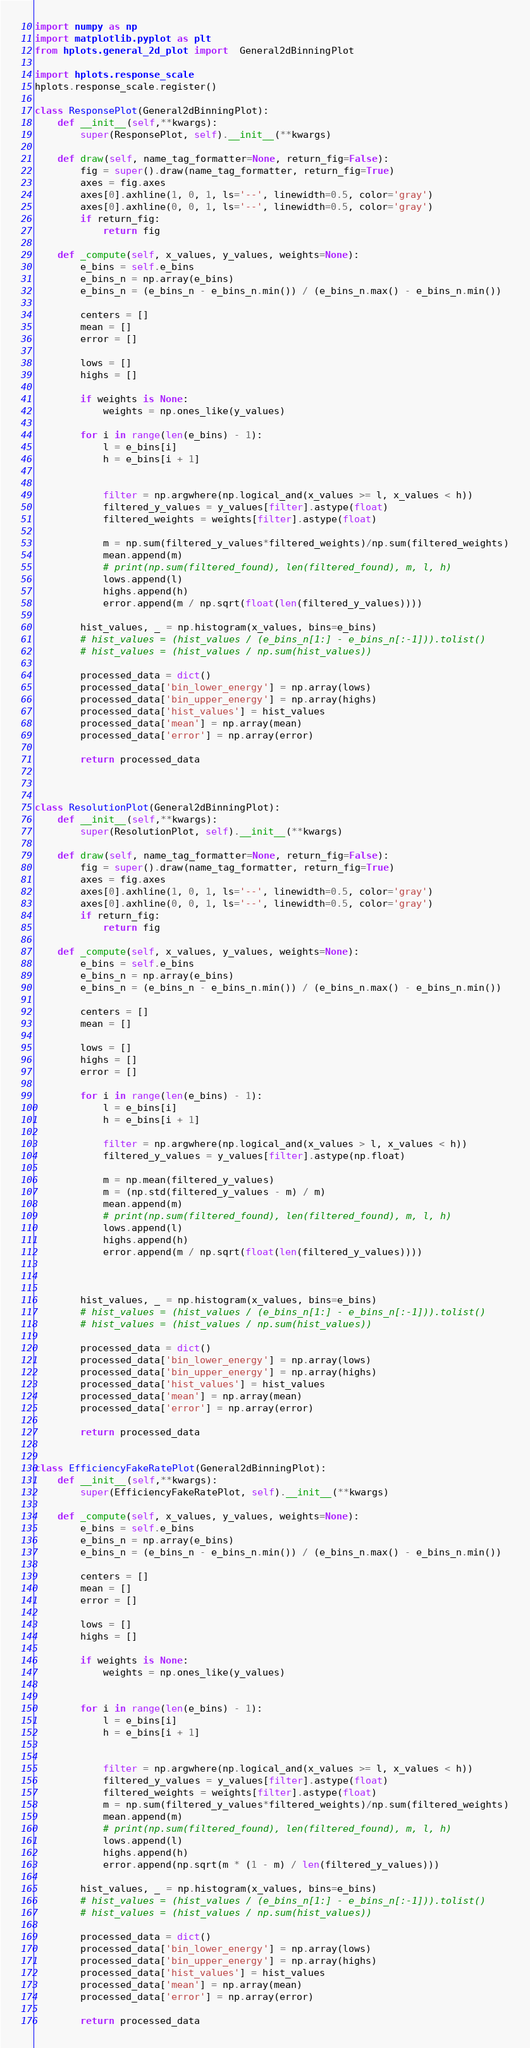Convert code to text. <code><loc_0><loc_0><loc_500><loc_500><_Python_>import numpy as np
import matplotlib.pyplot as plt
from hplots.general_2d_plot import  General2dBinningPlot

import hplots.response_scale
hplots.response_scale.register()

class ResponsePlot(General2dBinningPlot):
    def __init__(self,**kwargs):
        super(ResponsePlot, self).__init__(**kwargs)

    def draw(self, name_tag_formatter=None, return_fig=False):
        fig = super().draw(name_tag_formatter, return_fig=True)
        axes = fig.axes
        axes[0].axhline(1, 0, 1, ls='--', linewidth=0.5, color='gray')
        axes[0].axhline(0, 0, 1, ls='--', linewidth=0.5, color='gray')
        if return_fig:
            return fig

    def _compute(self, x_values, y_values, weights=None):
        e_bins = self.e_bins
        e_bins_n = np.array(e_bins)
        e_bins_n = (e_bins_n - e_bins_n.min()) / (e_bins_n.max() - e_bins_n.min())

        centers = []
        mean = []
        error = []

        lows = []
        highs = []

        if weights is None:
            weights = np.ones_like(y_values)

        for i in range(len(e_bins) - 1):
            l = e_bins[i]
            h = e_bins[i + 1]


            filter = np.argwhere(np.logical_and(x_values >= l, x_values < h))
            filtered_y_values = y_values[filter].astype(float)
            filtered_weights = weights[filter].astype(float)

            m = np.sum(filtered_y_values*filtered_weights)/np.sum(filtered_weights)
            mean.append(m)
            # print(np.sum(filtered_found), len(filtered_found), m, l, h)
            lows.append(l)
            highs.append(h)
            error.append(m / np.sqrt(float(len(filtered_y_values))))

        hist_values, _ = np.histogram(x_values, bins=e_bins)
        # hist_values = (hist_values / (e_bins_n[1:] - e_bins_n[:-1])).tolist()
        # hist_values = (hist_values / np.sum(hist_values))

        processed_data = dict()
        processed_data['bin_lower_energy'] = np.array(lows)
        processed_data['bin_upper_energy'] = np.array(highs)
        processed_data['hist_values'] = hist_values
        processed_data['mean'] = np.array(mean)
        processed_data['error'] = np.array(error)

        return processed_data



class ResolutionPlot(General2dBinningPlot):
    def __init__(self,**kwargs):
        super(ResolutionPlot, self).__init__(**kwargs)

    def draw(self, name_tag_formatter=None, return_fig=False):
        fig = super().draw(name_tag_formatter, return_fig=True)
        axes = fig.axes
        axes[0].axhline(1, 0, 1, ls='--', linewidth=0.5, color='gray')
        axes[0].axhline(0, 0, 1, ls='--', linewidth=0.5, color='gray')
        if return_fig:
            return fig

    def _compute(self, x_values, y_values, weights=None):
        e_bins = self.e_bins
        e_bins_n = np.array(e_bins)
        e_bins_n = (e_bins_n - e_bins_n.min()) / (e_bins_n.max() - e_bins_n.min())

        centers = []
        mean = []

        lows = []
        highs = []
        error = []

        for i in range(len(e_bins) - 1):
            l = e_bins[i]
            h = e_bins[i + 1]

            filter = np.argwhere(np.logical_and(x_values > l, x_values < h))
            filtered_y_values = y_values[filter].astype(np.float)

            m = np.mean(filtered_y_values)
            m = (np.std(filtered_y_values - m) / m)
            mean.append(m)
            # print(np.sum(filtered_found), len(filtered_found), m, l, h)
            lows.append(l)
            highs.append(h)
            error.append(m / np.sqrt(float(len(filtered_y_values))))



        hist_values, _ = np.histogram(x_values, bins=e_bins)
        # hist_values = (hist_values / (e_bins_n[1:] - e_bins_n[:-1])).tolist()
        # hist_values = (hist_values / np.sum(hist_values))

        processed_data = dict()
        processed_data['bin_lower_energy'] = np.array(lows)
        processed_data['bin_upper_energy'] = np.array(highs)
        processed_data['hist_values'] = hist_values
        processed_data['mean'] = np.array(mean)
        processed_data['error'] = np.array(error)

        return processed_data


class EfficiencyFakeRatePlot(General2dBinningPlot):
    def __init__(self,**kwargs):
        super(EfficiencyFakeRatePlot, self).__init__(**kwargs)

    def _compute(self, x_values, y_values, weights=None):
        e_bins = self.e_bins
        e_bins_n = np.array(e_bins)
        e_bins_n = (e_bins_n - e_bins_n.min()) / (e_bins_n.max() - e_bins_n.min())

        centers = []
        mean = []
        error = []

        lows = []
        highs = []

        if weights is None:
            weights = np.ones_like(y_values)


        for i in range(len(e_bins) - 1):
            l = e_bins[i]
            h = e_bins[i + 1]


            filter = np.argwhere(np.logical_and(x_values >= l, x_values < h))
            filtered_y_values = y_values[filter].astype(float)
            filtered_weights = weights[filter].astype(float)
            m = np.sum(filtered_y_values*filtered_weights)/np.sum(filtered_weights)
            mean.append(m)
            # print(np.sum(filtered_found), len(filtered_found), m, l, h)
            lows.append(l)
            highs.append(h)
            error.append(np.sqrt(m * (1 - m) / len(filtered_y_values)))

        hist_values, _ = np.histogram(x_values, bins=e_bins)
        # hist_values = (hist_values / (e_bins_n[1:] - e_bins_n[:-1])).tolist()
        # hist_values = (hist_values / np.sum(hist_values))

        processed_data = dict()
        processed_data['bin_lower_energy'] = np.array(lows)
        processed_data['bin_upper_energy'] = np.array(highs)
        processed_data['hist_values'] = hist_values
        processed_data['mean'] = np.array(mean)
        processed_data['error'] = np.array(error)

        return processed_data


</code> 